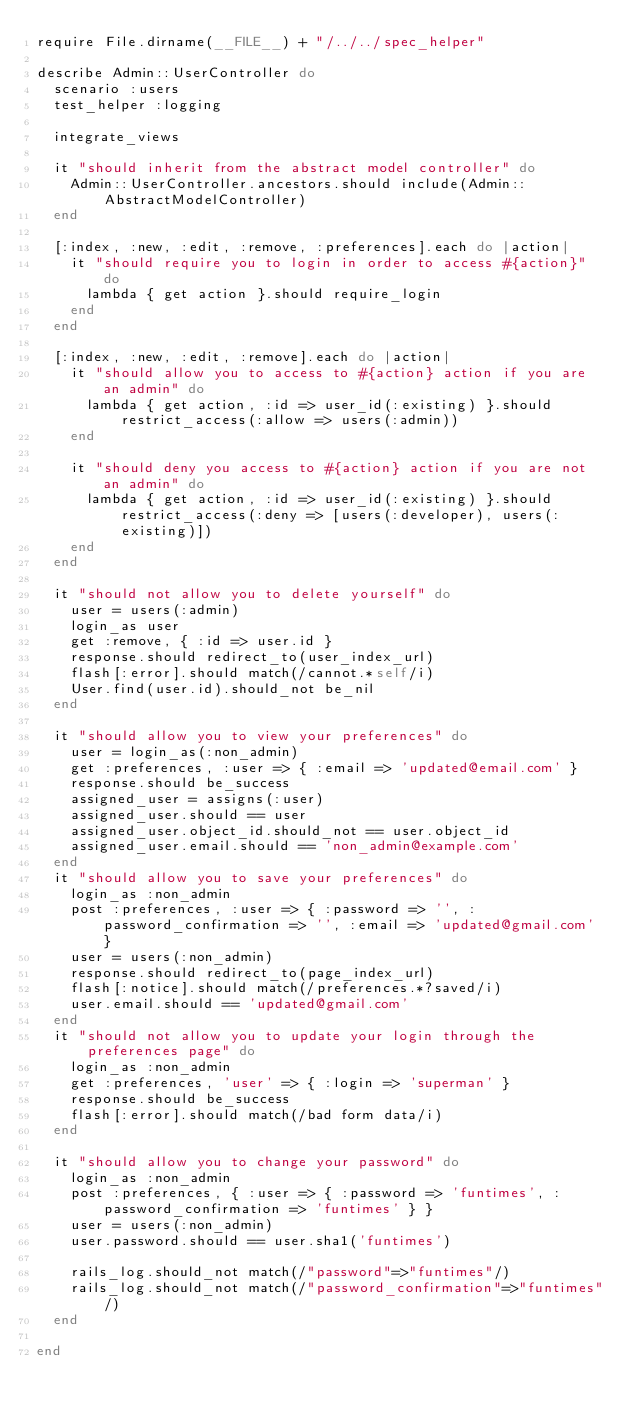Convert code to text. <code><loc_0><loc_0><loc_500><loc_500><_Ruby_>require File.dirname(__FILE__) + "/../../spec_helper"

describe Admin::UserController do
  scenario :users
  test_helper :logging
  
  integrate_views
  
  it "should inherit from the abstract model controller" do
    Admin::UserController.ancestors.should include(Admin::AbstractModelController)
  end
  
  [:index, :new, :edit, :remove, :preferences].each do |action|
    it "should require you to login in order to access #{action}" do
      lambda { get action }.should require_login
    end
  end
  
  [:index, :new, :edit, :remove].each do |action|
    it "should allow you to access to #{action} action if you are an admin" do
      lambda { get action, :id => user_id(:existing) }.should restrict_access(:allow => users(:admin))
    end
    
    it "should deny you access to #{action} action if you are not an admin" do
      lambda { get action, :id => user_id(:existing) }.should restrict_access(:deny => [users(:developer), users(:existing)])
    end
  end
  
  it "should not allow you to delete yourself" do
    user = users(:admin)
    login_as user
    get :remove, { :id => user.id }
    response.should redirect_to(user_index_url)
    flash[:error].should match(/cannot.*self/i)
    User.find(user.id).should_not be_nil
  end
  
  it "should allow you to view your preferences" do
    user = login_as(:non_admin)
    get :preferences, :user => { :email => 'updated@email.com' }
    response.should be_success
    assigned_user = assigns(:user)
    assigned_user.should == user
    assigned_user.object_id.should_not == user.object_id
    assigned_user.email.should == 'non_admin@example.com'
  end
  it "should allow you to save your preferences" do
    login_as :non_admin
    post :preferences, :user => { :password => '', :password_confirmation => '', :email => 'updated@gmail.com' }
    user = users(:non_admin)
    response.should redirect_to(page_index_url)
    flash[:notice].should match(/preferences.*?saved/i)
    user.email.should == 'updated@gmail.com'
  end
  it "should not allow you to update your login through the preferences page" do
    login_as :non_admin
    get :preferences, 'user' => { :login => 'superman' }
    response.should be_success
    flash[:error].should match(/bad form data/i)
  end
  
  it "should allow you to change your password" do
    login_as :non_admin
    post :preferences, { :user => { :password => 'funtimes', :password_confirmation => 'funtimes' } }
    user = users(:non_admin)
    user.password.should == user.sha1('funtimes')
    
    rails_log.should_not match(/"password"=>"funtimes"/)
    rails_log.should_not match(/"password_confirmation"=>"funtimes"/)
  end
  
end</code> 